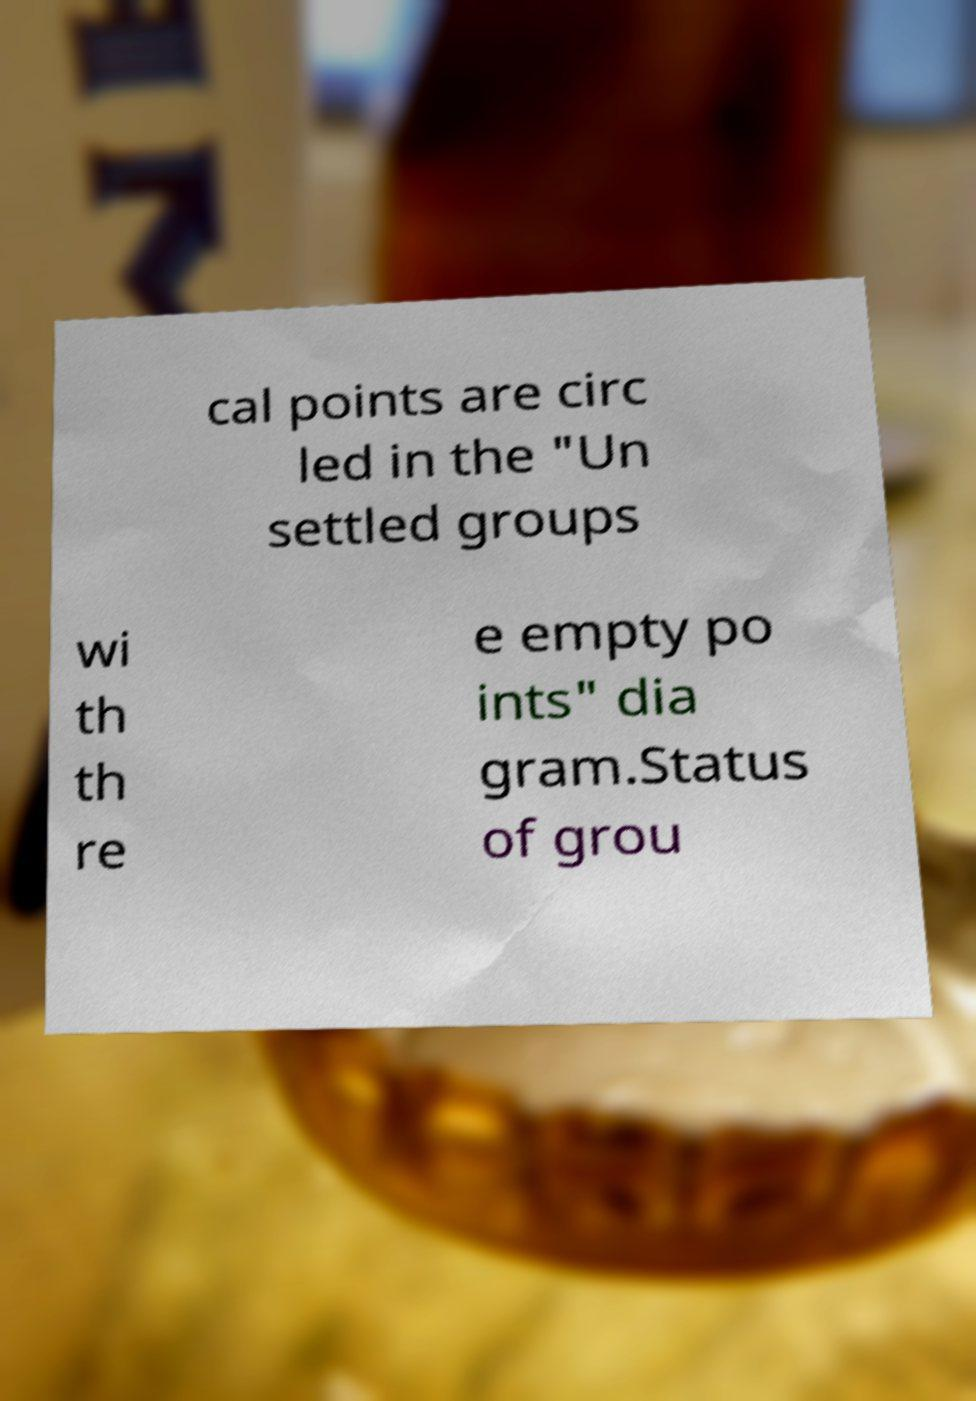I need the written content from this picture converted into text. Can you do that? cal points are circ led in the "Un settled groups wi th th re e empty po ints" dia gram.Status of grou 